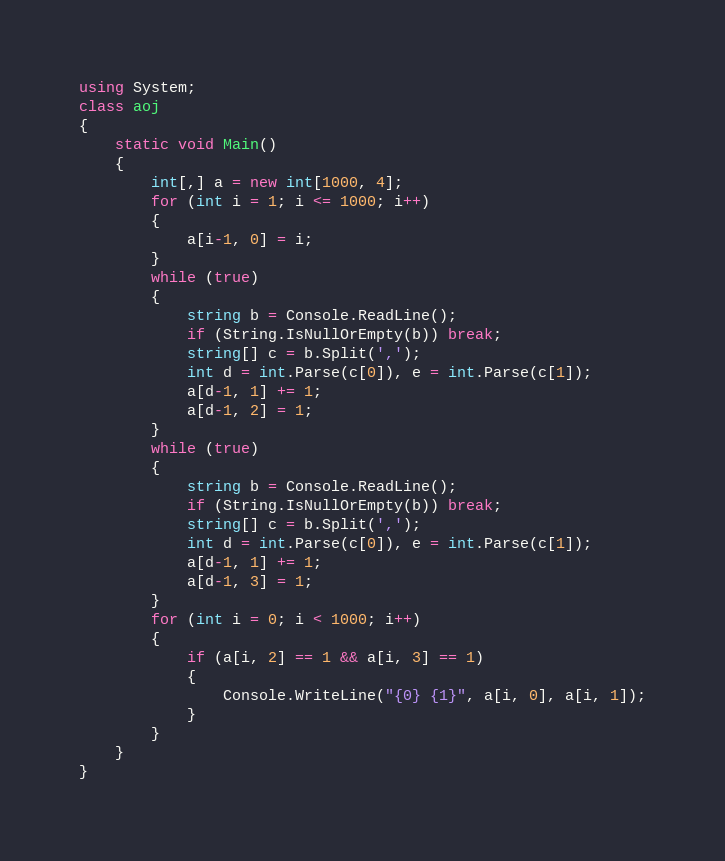<code> <loc_0><loc_0><loc_500><loc_500><_C#_>using System;
class aoj
{
    static void Main()
    {
        int[,] a = new int[1000, 4];
        for (int i = 1; i <= 1000; i++)
        {
            a[i-1, 0] = i;
        }
        while (true)
        {
            string b = Console.ReadLine();
            if (String.IsNullOrEmpty(b)) break;
            string[] c = b.Split(',');
            int d = int.Parse(c[0]), e = int.Parse(c[1]);
            a[d-1, 1] += 1;
            a[d-1, 2] = 1;
        }
        while (true)
        {
            string b = Console.ReadLine();
            if (String.IsNullOrEmpty(b)) break;
            string[] c = b.Split(',');
            int d = int.Parse(c[0]), e = int.Parse(c[1]);
            a[d-1, 1] += 1;
            a[d-1, 3] = 1;
        }
        for (int i = 0; i < 1000; i++)
        {
            if (a[i, 2] == 1 && a[i, 3] == 1)
            {
                Console.WriteLine("{0} {1}", a[i, 0], a[i, 1]);
            }
        }
    }
}</code> 